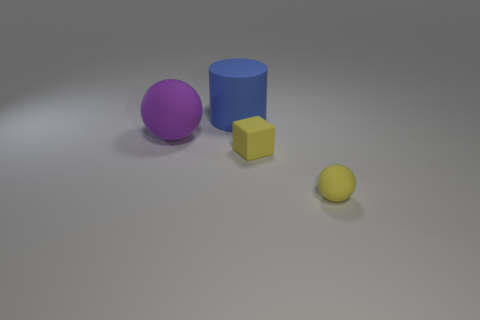Add 3 yellow blocks. How many objects exist? 7 Subtract all cylinders. How many objects are left? 3 Add 2 small green shiny cubes. How many small green shiny cubes exist? 2 Subtract 1 purple spheres. How many objects are left? 3 Subtract all tiny red rubber things. Subtract all blue objects. How many objects are left? 3 Add 1 big blue matte things. How many big blue matte things are left? 2 